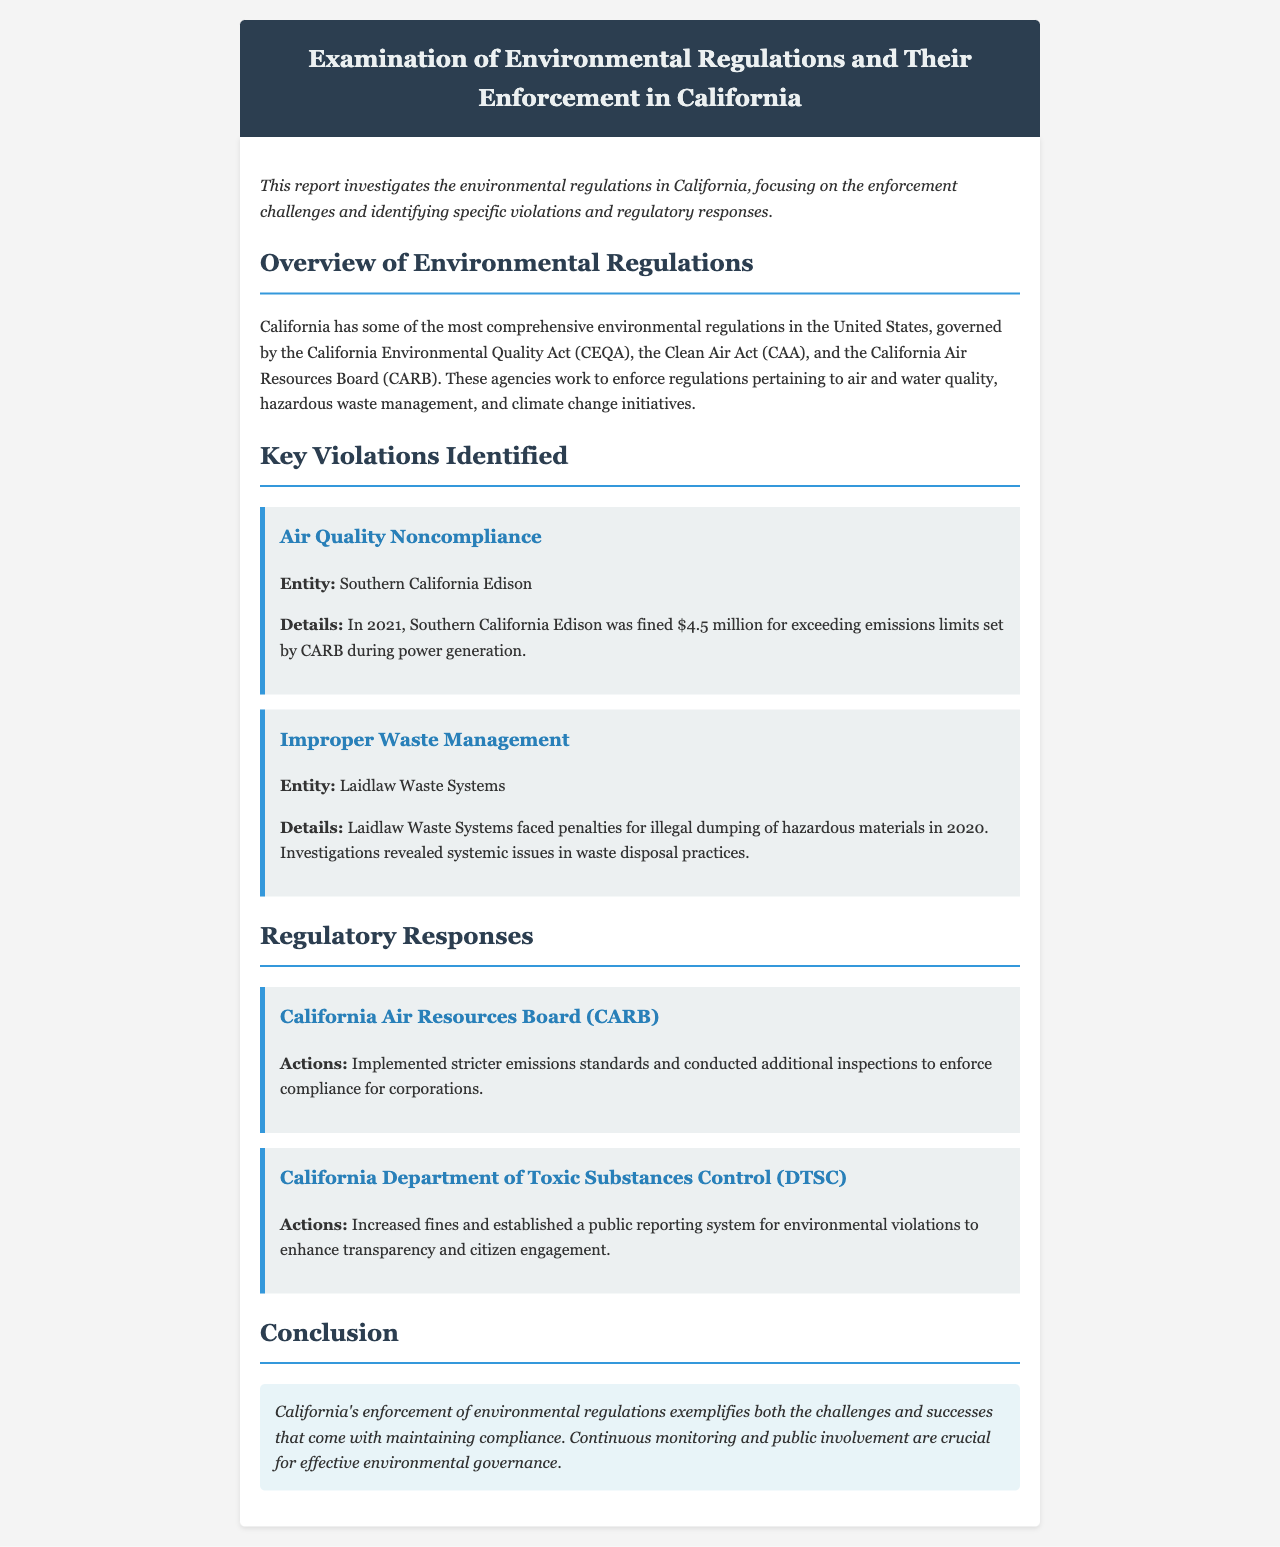What entity was fined for exceeding emissions limits? The document specifies that Southern California Edison was fined for this violation.
Answer: Southern California Edison What was the amount fined for Southern California Edison? The report states that the fine imposed on Southern California Edison was $4.5 million.
Answer: $4.5 million What type of violation did Laidlaw Waste Systems commit? The document mentions that they were penalized for illegal dumping of hazardous materials.
Answer: Illegal dumping of hazardous materials Which agency carried out stricter emissions standards? The report highlights that the California Air Resources Board (CARB) implemented stricter standards.
Answer: California Air Resources Board (CARB) What specific action did the DTSC take to enhance transparency? The document states that DTSC established a public reporting system for environmental violations.
Answer: Public reporting system What year did Laidlaw Waste Systems face penalties? According to the document, Laidlaw Waste Systems faced penalties in the year 2020.
Answer: 2020 What is the overarching legislation governing California's environmental regulations? The report identifies the California Environmental Quality Act (CEQA) as a key regulation.
Answer: California Environmental Quality Act (CEQA) What is a primary focus of the report? The document focuses on the enforcement challenges of environmental regulations in California.
Answer: Enforcement challenges 